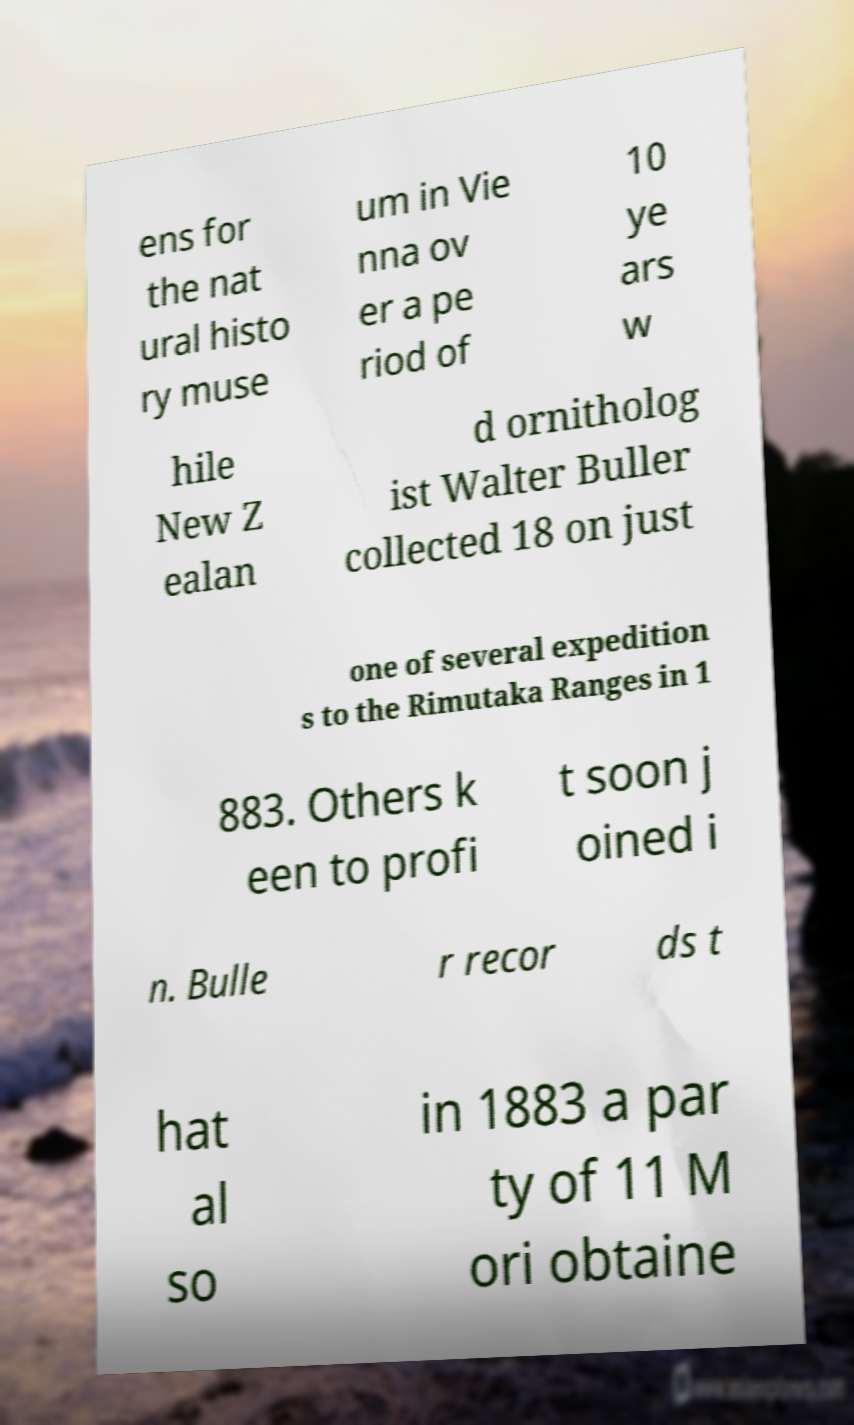There's text embedded in this image that I need extracted. Can you transcribe it verbatim? ens for the nat ural histo ry muse um in Vie nna ov er a pe riod of 10 ye ars w hile New Z ealan d ornitholog ist Walter Buller collected 18 on just one of several expedition s to the Rimutaka Ranges in 1 883. Others k een to profi t soon j oined i n. Bulle r recor ds t hat al so in 1883 a par ty of 11 M ori obtaine 